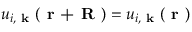<formula> <loc_0><loc_0><loc_500><loc_500>u _ { i , k } ( r + R ) = u _ { i , k } ( r )</formula> 